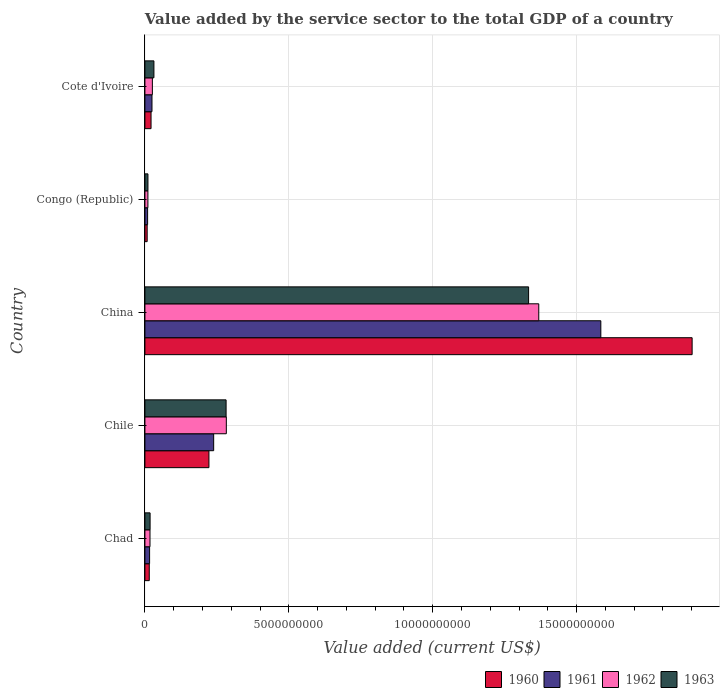What is the label of the 5th group of bars from the top?
Your response must be concise. Chad. What is the value added by the service sector to the total GDP in 1961 in Cote d'Ivoire?
Provide a short and direct response. 2.46e+08. Across all countries, what is the maximum value added by the service sector to the total GDP in 1962?
Keep it short and to the point. 1.37e+1. Across all countries, what is the minimum value added by the service sector to the total GDP in 1962?
Make the answer very short. 1.04e+08. In which country was the value added by the service sector to the total GDP in 1963 maximum?
Offer a very short reply. China. In which country was the value added by the service sector to the total GDP in 1960 minimum?
Your response must be concise. Congo (Republic). What is the total value added by the service sector to the total GDP in 1960 in the graph?
Your answer should be very brief. 2.17e+1. What is the difference between the value added by the service sector to the total GDP in 1963 in China and that in Congo (Republic)?
Keep it short and to the point. 1.32e+1. What is the difference between the value added by the service sector to the total GDP in 1960 in Chad and the value added by the service sector to the total GDP in 1963 in Cote d'Ivoire?
Offer a very short reply. -1.62e+08. What is the average value added by the service sector to the total GDP in 1963 per country?
Keep it short and to the point. 3.35e+09. What is the difference between the value added by the service sector to the total GDP in 1963 and value added by the service sector to the total GDP in 1960 in Chile?
Your answer should be compact. 5.96e+08. What is the ratio of the value added by the service sector to the total GDP in 1960 in Chile to that in China?
Give a very brief answer. 0.12. Is the difference between the value added by the service sector to the total GDP in 1963 in Congo (Republic) and Cote d'Ivoire greater than the difference between the value added by the service sector to the total GDP in 1960 in Congo (Republic) and Cote d'Ivoire?
Keep it short and to the point. No. What is the difference between the highest and the second highest value added by the service sector to the total GDP in 1963?
Your answer should be compact. 1.05e+1. What is the difference between the highest and the lowest value added by the service sector to the total GDP in 1960?
Keep it short and to the point. 1.89e+1. Is the sum of the value added by the service sector to the total GDP in 1960 in Chad and China greater than the maximum value added by the service sector to the total GDP in 1962 across all countries?
Your response must be concise. Yes. What does the 2nd bar from the top in Congo (Republic) represents?
Keep it short and to the point. 1962. Is it the case that in every country, the sum of the value added by the service sector to the total GDP in 1962 and value added by the service sector to the total GDP in 1963 is greater than the value added by the service sector to the total GDP in 1960?
Offer a terse response. Yes. How many bars are there?
Ensure brevity in your answer.  20. How many countries are there in the graph?
Provide a short and direct response. 5. What is the difference between two consecutive major ticks on the X-axis?
Provide a succinct answer. 5.00e+09. Where does the legend appear in the graph?
Provide a succinct answer. Bottom right. How are the legend labels stacked?
Make the answer very short. Horizontal. What is the title of the graph?
Make the answer very short. Value added by the service sector to the total GDP of a country. Does "2002" appear as one of the legend labels in the graph?
Ensure brevity in your answer.  No. What is the label or title of the X-axis?
Your response must be concise. Value added (current US$). What is the label or title of the Y-axis?
Provide a short and direct response. Country. What is the Value added (current US$) in 1960 in Chad?
Offer a very short reply. 1.51e+08. What is the Value added (current US$) in 1961 in Chad?
Your response must be concise. 1.62e+08. What is the Value added (current US$) in 1962 in Chad?
Your response must be concise. 1.76e+08. What is the Value added (current US$) of 1963 in Chad?
Make the answer very short. 1.80e+08. What is the Value added (current US$) in 1960 in Chile?
Offer a very short reply. 2.22e+09. What is the Value added (current US$) in 1961 in Chile?
Your answer should be compact. 2.39e+09. What is the Value added (current US$) in 1962 in Chile?
Offer a very short reply. 2.83e+09. What is the Value added (current US$) in 1963 in Chile?
Your response must be concise. 2.82e+09. What is the Value added (current US$) of 1960 in China?
Provide a succinct answer. 1.90e+1. What is the Value added (current US$) of 1961 in China?
Your answer should be compact. 1.58e+1. What is the Value added (current US$) of 1962 in China?
Your answer should be very brief. 1.37e+1. What is the Value added (current US$) of 1963 in China?
Provide a succinct answer. 1.33e+1. What is the Value added (current US$) in 1960 in Congo (Republic)?
Offer a very short reply. 7.82e+07. What is the Value added (current US$) in 1961 in Congo (Republic)?
Provide a short and direct response. 9.33e+07. What is the Value added (current US$) of 1962 in Congo (Republic)?
Provide a short and direct response. 1.04e+08. What is the Value added (current US$) of 1963 in Congo (Republic)?
Your response must be concise. 1.06e+08. What is the Value added (current US$) of 1960 in Cote d'Ivoire?
Your response must be concise. 2.13e+08. What is the Value added (current US$) of 1961 in Cote d'Ivoire?
Make the answer very short. 2.46e+08. What is the Value added (current US$) in 1962 in Cote d'Ivoire?
Ensure brevity in your answer.  2.59e+08. What is the Value added (current US$) in 1963 in Cote d'Ivoire?
Ensure brevity in your answer.  3.13e+08. Across all countries, what is the maximum Value added (current US$) in 1960?
Provide a succinct answer. 1.90e+1. Across all countries, what is the maximum Value added (current US$) in 1961?
Your answer should be very brief. 1.58e+1. Across all countries, what is the maximum Value added (current US$) in 1962?
Offer a very short reply. 1.37e+1. Across all countries, what is the maximum Value added (current US$) of 1963?
Provide a succinct answer. 1.33e+1. Across all countries, what is the minimum Value added (current US$) of 1960?
Offer a terse response. 7.82e+07. Across all countries, what is the minimum Value added (current US$) of 1961?
Provide a succinct answer. 9.33e+07. Across all countries, what is the minimum Value added (current US$) in 1962?
Your answer should be compact. 1.04e+08. Across all countries, what is the minimum Value added (current US$) of 1963?
Provide a short and direct response. 1.06e+08. What is the total Value added (current US$) of 1960 in the graph?
Your answer should be very brief. 2.17e+1. What is the total Value added (current US$) in 1961 in the graph?
Give a very brief answer. 1.87e+1. What is the total Value added (current US$) of 1962 in the graph?
Make the answer very short. 1.71e+1. What is the total Value added (current US$) of 1963 in the graph?
Your answer should be very brief. 1.68e+1. What is the difference between the Value added (current US$) of 1960 in Chad and that in Chile?
Your answer should be very brief. -2.07e+09. What is the difference between the Value added (current US$) of 1961 in Chad and that in Chile?
Offer a very short reply. -2.23e+09. What is the difference between the Value added (current US$) of 1962 in Chad and that in Chile?
Keep it short and to the point. -2.65e+09. What is the difference between the Value added (current US$) of 1963 in Chad and that in Chile?
Offer a very short reply. -2.64e+09. What is the difference between the Value added (current US$) in 1960 in Chad and that in China?
Your answer should be very brief. -1.89e+1. What is the difference between the Value added (current US$) in 1961 in Chad and that in China?
Offer a very short reply. -1.57e+1. What is the difference between the Value added (current US$) of 1962 in Chad and that in China?
Your response must be concise. -1.35e+1. What is the difference between the Value added (current US$) in 1963 in Chad and that in China?
Ensure brevity in your answer.  -1.32e+1. What is the difference between the Value added (current US$) of 1960 in Chad and that in Congo (Republic)?
Give a very brief answer. 7.27e+07. What is the difference between the Value added (current US$) in 1961 in Chad and that in Congo (Republic)?
Provide a short and direct response. 6.92e+07. What is the difference between the Value added (current US$) in 1962 in Chad and that in Congo (Republic)?
Provide a short and direct response. 7.25e+07. What is the difference between the Value added (current US$) of 1963 in Chad and that in Congo (Republic)?
Ensure brevity in your answer.  7.41e+07. What is the difference between the Value added (current US$) of 1960 in Chad and that in Cote d'Ivoire?
Provide a short and direct response. -6.18e+07. What is the difference between the Value added (current US$) of 1961 in Chad and that in Cote d'Ivoire?
Ensure brevity in your answer.  -8.31e+07. What is the difference between the Value added (current US$) in 1962 in Chad and that in Cote d'Ivoire?
Make the answer very short. -8.26e+07. What is the difference between the Value added (current US$) of 1963 in Chad and that in Cote d'Ivoire?
Your answer should be compact. -1.33e+08. What is the difference between the Value added (current US$) in 1960 in Chile and that in China?
Offer a terse response. -1.68e+1. What is the difference between the Value added (current US$) of 1961 in Chile and that in China?
Your answer should be compact. -1.35e+1. What is the difference between the Value added (current US$) in 1962 in Chile and that in China?
Provide a succinct answer. -1.09e+1. What is the difference between the Value added (current US$) of 1963 in Chile and that in China?
Provide a succinct answer. -1.05e+1. What is the difference between the Value added (current US$) of 1960 in Chile and that in Congo (Republic)?
Make the answer very short. 2.15e+09. What is the difference between the Value added (current US$) of 1961 in Chile and that in Congo (Republic)?
Make the answer very short. 2.30e+09. What is the difference between the Value added (current US$) in 1962 in Chile and that in Congo (Republic)?
Your response must be concise. 2.73e+09. What is the difference between the Value added (current US$) in 1963 in Chile and that in Congo (Republic)?
Ensure brevity in your answer.  2.72e+09. What is the difference between the Value added (current US$) in 1960 in Chile and that in Cote d'Ivoire?
Give a very brief answer. 2.01e+09. What is the difference between the Value added (current US$) of 1961 in Chile and that in Cote d'Ivoire?
Your response must be concise. 2.14e+09. What is the difference between the Value added (current US$) of 1962 in Chile and that in Cote d'Ivoire?
Your answer should be compact. 2.57e+09. What is the difference between the Value added (current US$) of 1963 in Chile and that in Cote d'Ivoire?
Ensure brevity in your answer.  2.51e+09. What is the difference between the Value added (current US$) in 1960 in China and that in Congo (Republic)?
Keep it short and to the point. 1.89e+1. What is the difference between the Value added (current US$) of 1961 in China and that in Congo (Republic)?
Make the answer very short. 1.57e+1. What is the difference between the Value added (current US$) of 1962 in China and that in Congo (Republic)?
Offer a terse response. 1.36e+1. What is the difference between the Value added (current US$) in 1963 in China and that in Congo (Republic)?
Ensure brevity in your answer.  1.32e+1. What is the difference between the Value added (current US$) in 1960 in China and that in Cote d'Ivoire?
Offer a very short reply. 1.88e+1. What is the difference between the Value added (current US$) in 1961 in China and that in Cote d'Ivoire?
Provide a short and direct response. 1.56e+1. What is the difference between the Value added (current US$) in 1962 in China and that in Cote d'Ivoire?
Keep it short and to the point. 1.34e+1. What is the difference between the Value added (current US$) in 1963 in China and that in Cote d'Ivoire?
Your answer should be very brief. 1.30e+1. What is the difference between the Value added (current US$) of 1960 in Congo (Republic) and that in Cote d'Ivoire?
Make the answer very short. -1.35e+08. What is the difference between the Value added (current US$) of 1961 in Congo (Republic) and that in Cote d'Ivoire?
Offer a very short reply. -1.52e+08. What is the difference between the Value added (current US$) in 1962 in Congo (Republic) and that in Cote d'Ivoire?
Make the answer very short. -1.55e+08. What is the difference between the Value added (current US$) in 1963 in Congo (Republic) and that in Cote d'Ivoire?
Offer a very short reply. -2.08e+08. What is the difference between the Value added (current US$) of 1960 in Chad and the Value added (current US$) of 1961 in Chile?
Your response must be concise. -2.24e+09. What is the difference between the Value added (current US$) of 1960 in Chad and the Value added (current US$) of 1962 in Chile?
Offer a very short reply. -2.68e+09. What is the difference between the Value added (current US$) of 1960 in Chad and the Value added (current US$) of 1963 in Chile?
Offer a very short reply. -2.67e+09. What is the difference between the Value added (current US$) in 1961 in Chad and the Value added (current US$) in 1962 in Chile?
Your answer should be compact. -2.67e+09. What is the difference between the Value added (current US$) of 1961 in Chad and the Value added (current US$) of 1963 in Chile?
Provide a short and direct response. -2.66e+09. What is the difference between the Value added (current US$) in 1962 in Chad and the Value added (current US$) in 1963 in Chile?
Provide a short and direct response. -2.64e+09. What is the difference between the Value added (current US$) of 1960 in Chad and the Value added (current US$) of 1961 in China?
Provide a succinct answer. -1.57e+1. What is the difference between the Value added (current US$) in 1960 in Chad and the Value added (current US$) in 1962 in China?
Offer a very short reply. -1.35e+1. What is the difference between the Value added (current US$) in 1960 in Chad and the Value added (current US$) in 1963 in China?
Your answer should be compact. -1.32e+1. What is the difference between the Value added (current US$) in 1961 in Chad and the Value added (current US$) in 1962 in China?
Make the answer very short. -1.35e+1. What is the difference between the Value added (current US$) of 1961 in Chad and the Value added (current US$) of 1963 in China?
Your response must be concise. -1.32e+1. What is the difference between the Value added (current US$) of 1962 in Chad and the Value added (current US$) of 1963 in China?
Provide a succinct answer. -1.32e+1. What is the difference between the Value added (current US$) in 1960 in Chad and the Value added (current US$) in 1961 in Congo (Republic)?
Offer a terse response. 5.77e+07. What is the difference between the Value added (current US$) of 1960 in Chad and the Value added (current US$) of 1962 in Congo (Republic)?
Make the answer very short. 4.72e+07. What is the difference between the Value added (current US$) in 1960 in Chad and the Value added (current US$) in 1963 in Congo (Republic)?
Ensure brevity in your answer.  4.54e+07. What is the difference between the Value added (current US$) in 1961 in Chad and the Value added (current US$) in 1962 in Congo (Republic)?
Keep it short and to the point. 5.87e+07. What is the difference between the Value added (current US$) of 1961 in Chad and the Value added (current US$) of 1963 in Congo (Republic)?
Offer a very short reply. 5.69e+07. What is the difference between the Value added (current US$) of 1962 in Chad and the Value added (current US$) of 1963 in Congo (Republic)?
Provide a short and direct response. 7.08e+07. What is the difference between the Value added (current US$) in 1960 in Chad and the Value added (current US$) in 1961 in Cote d'Ivoire?
Your answer should be very brief. -9.46e+07. What is the difference between the Value added (current US$) of 1960 in Chad and the Value added (current US$) of 1962 in Cote d'Ivoire?
Make the answer very short. -1.08e+08. What is the difference between the Value added (current US$) of 1960 in Chad and the Value added (current US$) of 1963 in Cote d'Ivoire?
Offer a very short reply. -1.62e+08. What is the difference between the Value added (current US$) in 1961 in Chad and the Value added (current US$) in 1962 in Cote d'Ivoire?
Offer a terse response. -9.64e+07. What is the difference between the Value added (current US$) in 1961 in Chad and the Value added (current US$) in 1963 in Cote d'Ivoire?
Your answer should be very brief. -1.51e+08. What is the difference between the Value added (current US$) of 1962 in Chad and the Value added (current US$) of 1963 in Cote d'Ivoire?
Make the answer very short. -1.37e+08. What is the difference between the Value added (current US$) of 1960 in Chile and the Value added (current US$) of 1961 in China?
Provide a short and direct response. -1.36e+1. What is the difference between the Value added (current US$) of 1960 in Chile and the Value added (current US$) of 1962 in China?
Offer a terse response. -1.15e+1. What is the difference between the Value added (current US$) of 1960 in Chile and the Value added (current US$) of 1963 in China?
Provide a succinct answer. -1.11e+1. What is the difference between the Value added (current US$) in 1961 in Chile and the Value added (current US$) in 1962 in China?
Ensure brevity in your answer.  -1.13e+1. What is the difference between the Value added (current US$) in 1961 in Chile and the Value added (current US$) in 1963 in China?
Keep it short and to the point. -1.09e+1. What is the difference between the Value added (current US$) in 1962 in Chile and the Value added (current US$) in 1963 in China?
Your response must be concise. -1.05e+1. What is the difference between the Value added (current US$) of 1960 in Chile and the Value added (current US$) of 1961 in Congo (Republic)?
Your answer should be very brief. 2.13e+09. What is the difference between the Value added (current US$) in 1960 in Chile and the Value added (current US$) in 1962 in Congo (Republic)?
Your response must be concise. 2.12e+09. What is the difference between the Value added (current US$) of 1960 in Chile and the Value added (current US$) of 1963 in Congo (Republic)?
Your answer should be very brief. 2.12e+09. What is the difference between the Value added (current US$) in 1961 in Chile and the Value added (current US$) in 1962 in Congo (Republic)?
Offer a terse response. 2.29e+09. What is the difference between the Value added (current US$) of 1961 in Chile and the Value added (current US$) of 1963 in Congo (Republic)?
Your response must be concise. 2.28e+09. What is the difference between the Value added (current US$) in 1962 in Chile and the Value added (current US$) in 1963 in Congo (Republic)?
Give a very brief answer. 2.72e+09. What is the difference between the Value added (current US$) of 1960 in Chile and the Value added (current US$) of 1961 in Cote d'Ivoire?
Keep it short and to the point. 1.98e+09. What is the difference between the Value added (current US$) in 1960 in Chile and the Value added (current US$) in 1962 in Cote d'Ivoire?
Your answer should be compact. 1.97e+09. What is the difference between the Value added (current US$) of 1960 in Chile and the Value added (current US$) of 1963 in Cote d'Ivoire?
Your answer should be very brief. 1.91e+09. What is the difference between the Value added (current US$) of 1961 in Chile and the Value added (current US$) of 1962 in Cote d'Ivoire?
Give a very brief answer. 2.13e+09. What is the difference between the Value added (current US$) of 1961 in Chile and the Value added (current US$) of 1963 in Cote d'Ivoire?
Your answer should be compact. 2.08e+09. What is the difference between the Value added (current US$) in 1962 in Chile and the Value added (current US$) in 1963 in Cote d'Ivoire?
Your answer should be compact. 2.52e+09. What is the difference between the Value added (current US$) of 1960 in China and the Value added (current US$) of 1961 in Congo (Republic)?
Keep it short and to the point. 1.89e+1. What is the difference between the Value added (current US$) in 1960 in China and the Value added (current US$) in 1962 in Congo (Republic)?
Your response must be concise. 1.89e+1. What is the difference between the Value added (current US$) in 1960 in China and the Value added (current US$) in 1963 in Congo (Republic)?
Give a very brief answer. 1.89e+1. What is the difference between the Value added (current US$) in 1961 in China and the Value added (current US$) in 1962 in Congo (Republic)?
Make the answer very short. 1.57e+1. What is the difference between the Value added (current US$) in 1961 in China and the Value added (current US$) in 1963 in Congo (Republic)?
Offer a very short reply. 1.57e+1. What is the difference between the Value added (current US$) of 1962 in China and the Value added (current US$) of 1963 in Congo (Republic)?
Provide a succinct answer. 1.36e+1. What is the difference between the Value added (current US$) of 1960 in China and the Value added (current US$) of 1961 in Cote d'Ivoire?
Provide a succinct answer. 1.88e+1. What is the difference between the Value added (current US$) of 1960 in China and the Value added (current US$) of 1962 in Cote d'Ivoire?
Provide a succinct answer. 1.88e+1. What is the difference between the Value added (current US$) in 1960 in China and the Value added (current US$) in 1963 in Cote d'Ivoire?
Your response must be concise. 1.87e+1. What is the difference between the Value added (current US$) of 1961 in China and the Value added (current US$) of 1962 in Cote d'Ivoire?
Your answer should be compact. 1.56e+1. What is the difference between the Value added (current US$) of 1961 in China and the Value added (current US$) of 1963 in Cote d'Ivoire?
Ensure brevity in your answer.  1.55e+1. What is the difference between the Value added (current US$) of 1962 in China and the Value added (current US$) of 1963 in Cote d'Ivoire?
Your answer should be very brief. 1.34e+1. What is the difference between the Value added (current US$) in 1960 in Congo (Republic) and the Value added (current US$) in 1961 in Cote d'Ivoire?
Provide a short and direct response. -1.67e+08. What is the difference between the Value added (current US$) of 1960 in Congo (Republic) and the Value added (current US$) of 1962 in Cote d'Ivoire?
Keep it short and to the point. -1.81e+08. What is the difference between the Value added (current US$) of 1960 in Congo (Republic) and the Value added (current US$) of 1963 in Cote d'Ivoire?
Make the answer very short. -2.35e+08. What is the difference between the Value added (current US$) in 1961 in Congo (Republic) and the Value added (current US$) in 1962 in Cote d'Ivoire?
Offer a very short reply. -1.66e+08. What is the difference between the Value added (current US$) of 1961 in Congo (Republic) and the Value added (current US$) of 1963 in Cote d'Ivoire?
Provide a short and direct response. -2.20e+08. What is the difference between the Value added (current US$) in 1962 in Congo (Republic) and the Value added (current US$) in 1963 in Cote d'Ivoire?
Give a very brief answer. -2.09e+08. What is the average Value added (current US$) in 1960 per country?
Your response must be concise. 4.34e+09. What is the average Value added (current US$) in 1961 per country?
Your answer should be very brief. 3.75e+09. What is the average Value added (current US$) of 1962 per country?
Your answer should be compact. 3.41e+09. What is the average Value added (current US$) in 1963 per country?
Make the answer very short. 3.35e+09. What is the difference between the Value added (current US$) of 1960 and Value added (current US$) of 1961 in Chad?
Provide a short and direct response. -1.15e+07. What is the difference between the Value added (current US$) of 1960 and Value added (current US$) of 1962 in Chad?
Ensure brevity in your answer.  -2.53e+07. What is the difference between the Value added (current US$) in 1960 and Value added (current US$) in 1963 in Chad?
Make the answer very short. -2.87e+07. What is the difference between the Value added (current US$) in 1961 and Value added (current US$) in 1962 in Chad?
Your answer should be compact. -1.38e+07. What is the difference between the Value added (current US$) in 1961 and Value added (current US$) in 1963 in Chad?
Your answer should be very brief. -1.71e+07. What is the difference between the Value added (current US$) of 1962 and Value added (current US$) of 1963 in Chad?
Your answer should be very brief. -3.34e+06. What is the difference between the Value added (current US$) of 1960 and Value added (current US$) of 1961 in Chile?
Your answer should be very brief. -1.64e+08. What is the difference between the Value added (current US$) in 1960 and Value added (current US$) in 1962 in Chile?
Offer a very short reply. -6.04e+08. What is the difference between the Value added (current US$) of 1960 and Value added (current US$) of 1963 in Chile?
Give a very brief answer. -5.96e+08. What is the difference between the Value added (current US$) of 1961 and Value added (current US$) of 1962 in Chile?
Make the answer very short. -4.40e+08. What is the difference between the Value added (current US$) of 1961 and Value added (current US$) of 1963 in Chile?
Offer a very short reply. -4.32e+08. What is the difference between the Value added (current US$) of 1962 and Value added (current US$) of 1963 in Chile?
Keep it short and to the point. 8.01e+06. What is the difference between the Value added (current US$) of 1960 and Value added (current US$) of 1961 in China?
Offer a terse response. 3.17e+09. What is the difference between the Value added (current US$) of 1960 and Value added (current US$) of 1962 in China?
Ensure brevity in your answer.  5.33e+09. What is the difference between the Value added (current US$) in 1960 and Value added (current US$) in 1963 in China?
Offer a very short reply. 5.68e+09. What is the difference between the Value added (current US$) in 1961 and Value added (current US$) in 1962 in China?
Your answer should be very brief. 2.16e+09. What is the difference between the Value added (current US$) of 1961 and Value added (current US$) of 1963 in China?
Provide a short and direct response. 2.51e+09. What is the difference between the Value added (current US$) of 1962 and Value added (current US$) of 1963 in China?
Ensure brevity in your answer.  3.53e+08. What is the difference between the Value added (current US$) of 1960 and Value added (current US$) of 1961 in Congo (Republic)?
Ensure brevity in your answer.  -1.51e+07. What is the difference between the Value added (current US$) in 1960 and Value added (current US$) in 1962 in Congo (Republic)?
Your response must be concise. -2.55e+07. What is the difference between the Value added (current US$) of 1960 and Value added (current US$) of 1963 in Congo (Republic)?
Give a very brief answer. -2.73e+07. What is the difference between the Value added (current US$) of 1961 and Value added (current US$) of 1962 in Congo (Republic)?
Your answer should be very brief. -1.05e+07. What is the difference between the Value added (current US$) of 1961 and Value added (current US$) of 1963 in Congo (Republic)?
Ensure brevity in your answer.  -1.23e+07. What is the difference between the Value added (current US$) of 1962 and Value added (current US$) of 1963 in Congo (Republic)?
Your answer should be very brief. -1.79e+06. What is the difference between the Value added (current US$) in 1960 and Value added (current US$) in 1961 in Cote d'Ivoire?
Your answer should be very brief. -3.28e+07. What is the difference between the Value added (current US$) in 1960 and Value added (current US$) in 1962 in Cote d'Ivoire?
Your answer should be compact. -4.61e+07. What is the difference between the Value added (current US$) in 1960 and Value added (current US$) in 1963 in Cote d'Ivoire?
Provide a succinct answer. -1.00e+08. What is the difference between the Value added (current US$) of 1961 and Value added (current US$) of 1962 in Cote d'Ivoire?
Provide a short and direct response. -1.33e+07. What is the difference between the Value added (current US$) in 1961 and Value added (current US$) in 1963 in Cote d'Ivoire?
Provide a short and direct response. -6.75e+07. What is the difference between the Value added (current US$) of 1962 and Value added (current US$) of 1963 in Cote d'Ivoire?
Offer a terse response. -5.42e+07. What is the ratio of the Value added (current US$) of 1960 in Chad to that in Chile?
Your answer should be very brief. 0.07. What is the ratio of the Value added (current US$) of 1961 in Chad to that in Chile?
Your answer should be very brief. 0.07. What is the ratio of the Value added (current US$) in 1962 in Chad to that in Chile?
Provide a short and direct response. 0.06. What is the ratio of the Value added (current US$) in 1963 in Chad to that in Chile?
Provide a succinct answer. 0.06. What is the ratio of the Value added (current US$) of 1960 in Chad to that in China?
Your answer should be very brief. 0.01. What is the ratio of the Value added (current US$) of 1961 in Chad to that in China?
Give a very brief answer. 0.01. What is the ratio of the Value added (current US$) of 1962 in Chad to that in China?
Ensure brevity in your answer.  0.01. What is the ratio of the Value added (current US$) of 1963 in Chad to that in China?
Provide a succinct answer. 0.01. What is the ratio of the Value added (current US$) in 1960 in Chad to that in Congo (Republic)?
Your response must be concise. 1.93. What is the ratio of the Value added (current US$) in 1961 in Chad to that in Congo (Republic)?
Give a very brief answer. 1.74. What is the ratio of the Value added (current US$) of 1962 in Chad to that in Congo (Republic)?
Provide a short and direct response. 1.7. What is the ratio of the Value added (current US$) of 1963 in Chad to that in Congo (Republic)?
Your response must be concise. 1.7. What is the ratio of the Value added (current US$) of 1960 in Chad to that in Cote d'Ivoire?
Ensure brevity in your answer.  0.71. What is the ratio of the Value added (current US$) in 1961 in Chad to that in Cote d'Ivoire?
Keep it short and to the point. 0.66. What is the ratio of the Value added (current US$) in 1962 in Chad to that in Cote d'Ivoire?
Give a very brief answer. 0.68. What is the ratio of the Value added (current US$) of 1963 in Chad to that in Cote d'Ivoire?
Provide a short and direct response. 0.57. What is the ratio of the Value added (current US$) in 1960 in Chile to that in China?
Your answer should be very brief. 0.12. What is the ratio of the Value added (current US$) of 1961 in Chile to that in China?
Your answer should be compact. 0.15. What is the ratio of the Value added (current US$) in 1962 in Chile to that in China?
Provide a succinct answer. 0.21. What is the ratio of the Value added (current US$) in 1963 in Chile to that in China?
Your answer should be very brief. 0.21. What is the ratio of the Value added (current US$) of 1960 in Chile to that in Congo (Republic)?
Ensure brevity in your answer.  28.44. What is the ratio of the Value added (current US$) in 1961 in Chile to that in Congo (Republic)?
Provide a short and direct response. 25.61. What is the ratio of the Value added (current US$) of 1962 in Chile to that in Congo (Republic)?
Offer a terse response. 27.27. What is the ratio of the Value added (current US$) in 1963 in Chile to that in Congo (Republic)?
Make the answer very short. 26.73. What is the ratio of the Value added (current US$) in 1960 in Chile to that in Cote d'Ivoire?
Make the answer very short. 10.45. What is the ratio of the Value added (current US$) in 1961 in Chile to that in Cote d'Ivoire?
Ensure brevity in your answer.  9.73. What is the ratio of the Value added (current US$) of 1962 in Chile to that in Cote d'Ivoire?
Your answer should be compact. 10.93. What is the ratio of the Value added (current US$) in 1963 in Chile to that in Cote d'Ivoire?
Keep it short and to the point. 9.01. What is the ratio of the Value added (current US$) of 1960 in China to that in Congo (Republic)?
Give a very brief answer. 243.12. What is the ratio of the Value added (current US$) of 1961 in China to that in Congo (Republic)?
Offer a very short reply. 169.84. What is the ratio of the Value added (current US$) in 1962 in China to that in Congo (Republic)?
Give a very brief answer. 131.91. What is the ratio of the Value added (current US$) of 1963 in China to that in Congo (Republic)?
Offer a terse response. 126.33. What is the ratio of the Value added (current US$) in 1960 in China to that in Cote d'Ivoire?
Your answer should be compact. 89.37. What is the ratio of the Value added (current US$) in 1961 in China to that in Cote d'Ivoire?
Your response must be concise. 64.52. What is the ratio of the Value added (current US$) of 1962 in China to that in Cote d'Ivoire?
Give a very brief answer. 52.87. What is the ratio of the Value added (current US$) in 1963 in China to that in Cote d'Ivoire?
Offer a terse response. 42.59. What is the ratio of the Value added (current US$) in 1960 in Congo (Republic) to that in Cote d'Ivoire?
Offer a very short reply. 0.37. What is the ratio of the Value added (current US$) of 1961 in Congo (Republic) to that in Cote d'Ivoire?
Offer a terse response. 0.38. What is the ratio of the Value added (current US$) of 1962 in Congo (Republic) to that in Cote d'Ivoire?
Your answer should be compact. 0.4. What is the ratio of the Value added (current US$) in 1963 in Congo (Republic) to that in Cote d'Ivoire?
Your answer should be very brief. 0.34. What is the difference between the highest and the second highest Value added (current US$) of 1960?
Provide a succinct answer. 1.68e+1. What is the difference between the highest and the second highest Value added (current US$) of 1961?
Offer a very short reply. 1.35e+1. What is the difference between the highest and the second highest Value added (current US$) in 1962?
Give a very brief answer. 1.09e+1. What is the difference between the highest and the second highest Value added (current US$) of 1963?
Provide a short and direct response. 1.05e+1. What is the difference between the highest and the lowest Value added (current US$) of 1960?
Keep it short and to the point. 1.89e+1. What is the difference between the highest and the lowest Value added (current US$) in 1961?
Offer a very short reply. 1.57e+1. What is the difference between the highest and the lowest Value added (current US$) of 1962?
Your response must be concise. 1.36e+1. What is the difference between the highest and the lowest Value added (current US$) in 1963?
Your answer should be very brief. 1.32e+1. 